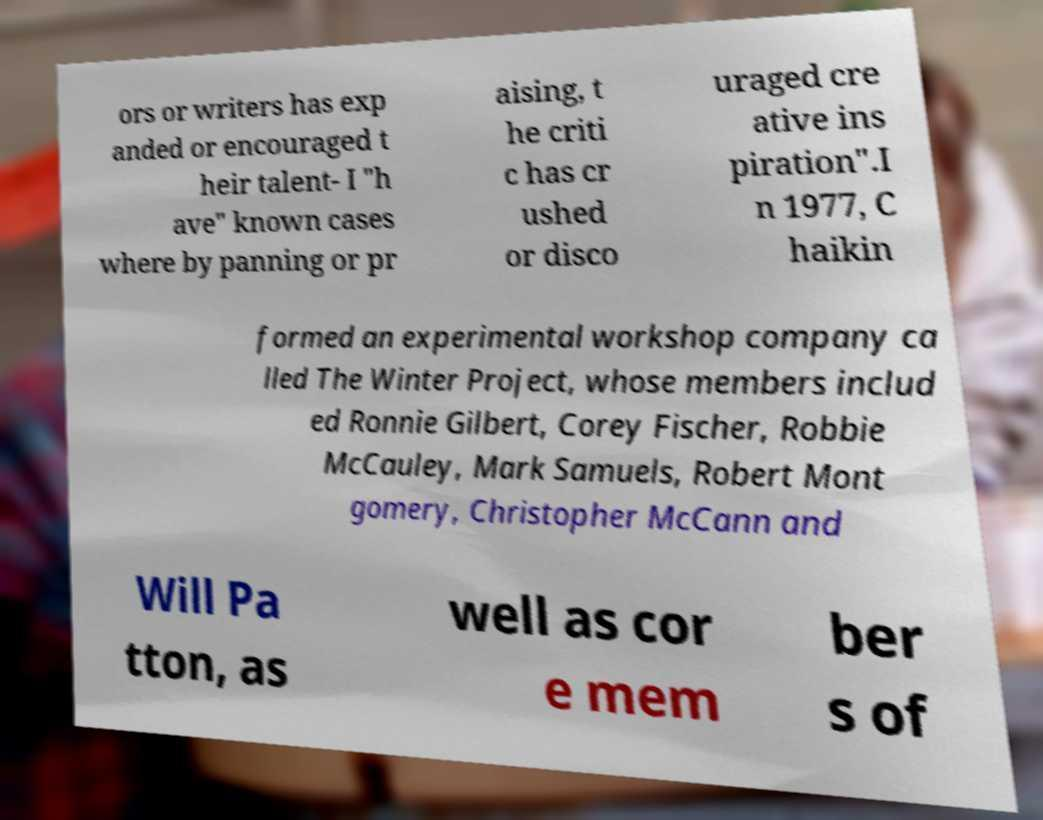Can you accurately transcribe the text from the provided image for me? ors or writers has exp anded or encouraged t heir talent- I "h ave" known cases where by panning or pr aising, t he criti c has cr ushed or disco uraged cre ative ins piration".I n 1977, C haikin formed an experimental workshop company ca lled The Winter Project, whose members includ ed Ronnie Gilbert, Corey Fischer, Robbie McCauley, Mark Samuels, Robert Mont gomery, Christopher McCann and Will Pa tton, as well as cor e mem ber s of 